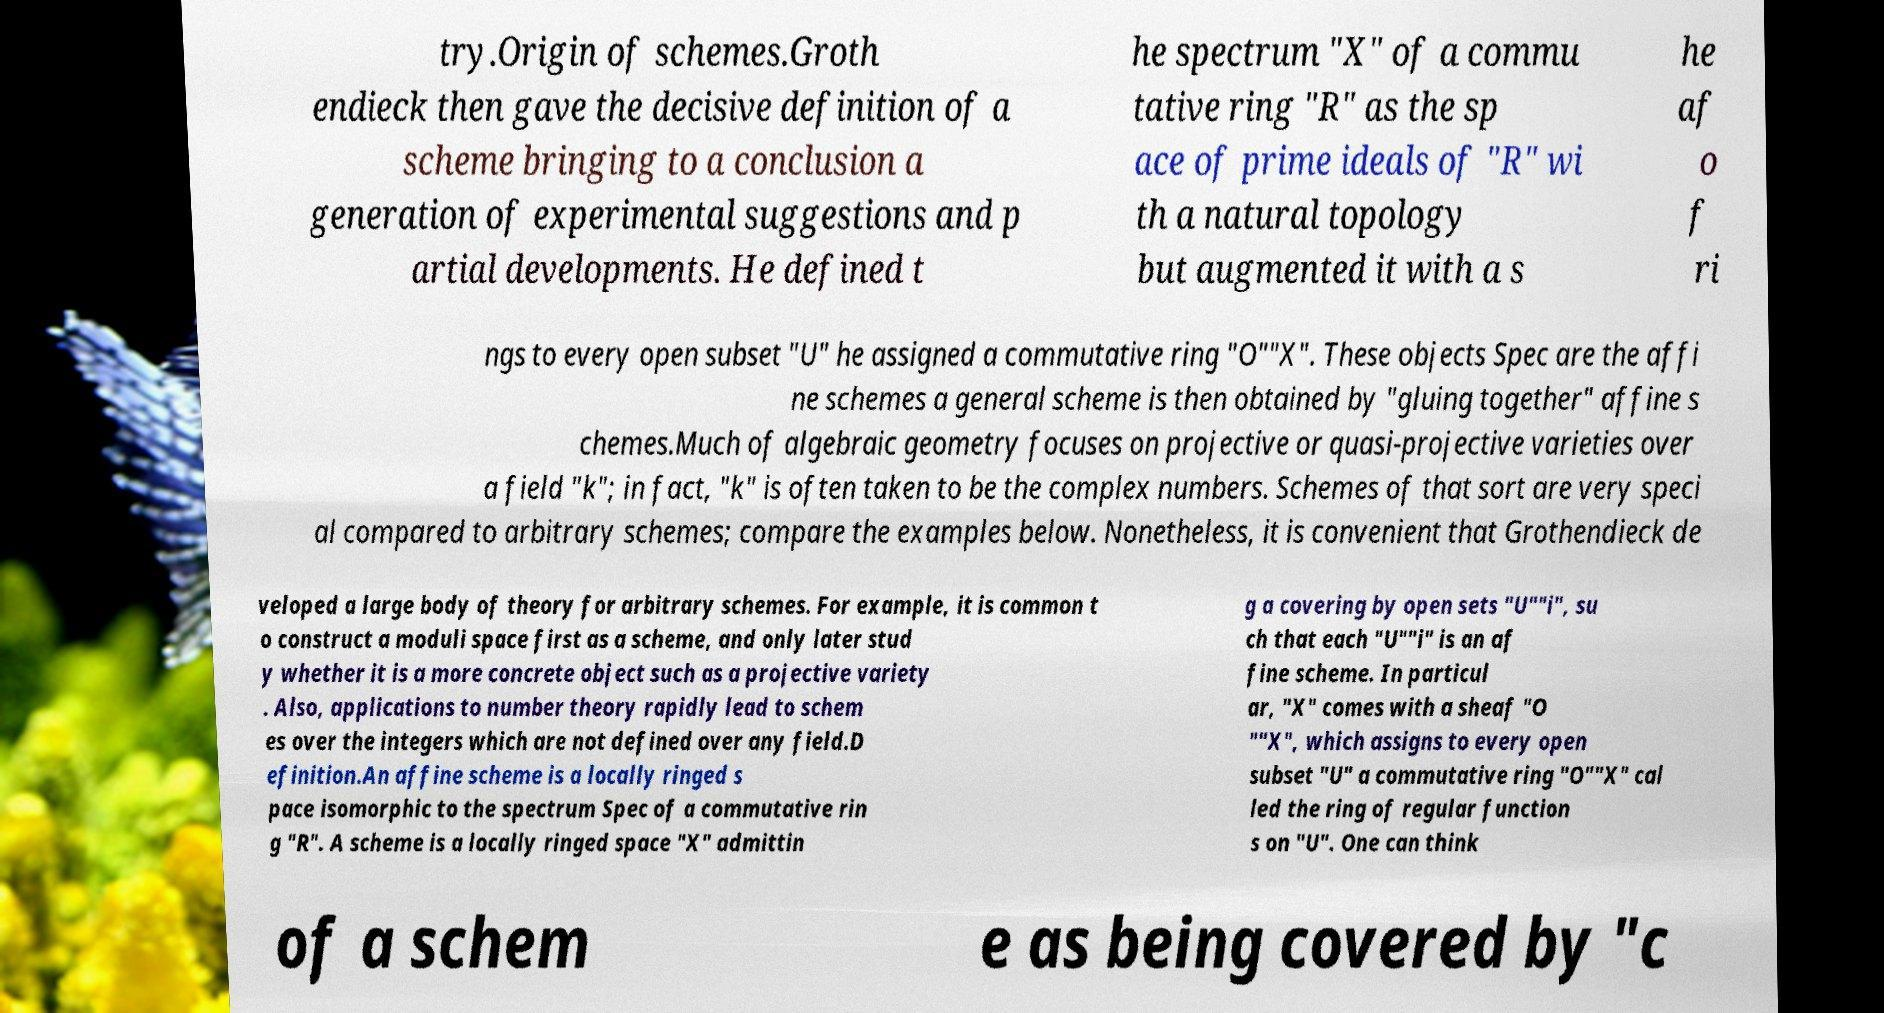Can you accurately transcribe the text from the provided image for me? try.Origin of schemes.Groth endieck then gave the decisive definition of a scheme bringing to a conclusion a generation of experimental suggestions and p artial developments. He defined t he spectrum "X" of a commu tative ring "R" as the sp ace of prime ideals of "R" wi th a natural topology but augmented it with a s he af o f ri ngs to every open subset "U" he assigned a commutative ring "O""X". These objects Spec are the affi ne schemes a general scheme is then obtained by "gluing together" affine s chemes.Much of algebraic geometry focuses on projective or quasi-projective varieties over a field "k"; in fact, "k" is often taken to be the complex numbers. Schemes of that sort are very speci al compared to arbitrary schemes; compare the examples below. Nonetheless, it is convenient that Grothendieck de veloped a large body of theory for arbitrary schemes. For example, it is common t o construct a moduli space first as a scheme, and only later stud y whether it is a more concrete object such as a projective variety . Also, applications to number theory rapidly lead to schem es over the integers which are not defined over any field.D efinition.An affine scheme is a locally ringed s pace isomorphic to the spectrum Spec of a commutative rin g "R". A scheme is a locally ringed space "X" admittin g a covering by open sets "U""i", su ch that each "U""i" is an af fine scheme. In particul ar, "X" comes with a sheaf "O ""X", which assigns to every open subset "U" a commutative ring "O""X" cal led the ring of regular function s on "U". One can think of a schem e as being covered by "c 